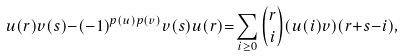<formula> <loc_0><loc_0><loc_500><loc_500>u ( r ) v ( s ) { - } ( - 1 ) ^ { p ( u ) p ( v ) } v ( s ) u ( r ) { = } \sum _ { i \geq 0 } \binom { r } { i } ( u ( i ) v ) ( r { + } s { - } i ) ,</formula> 